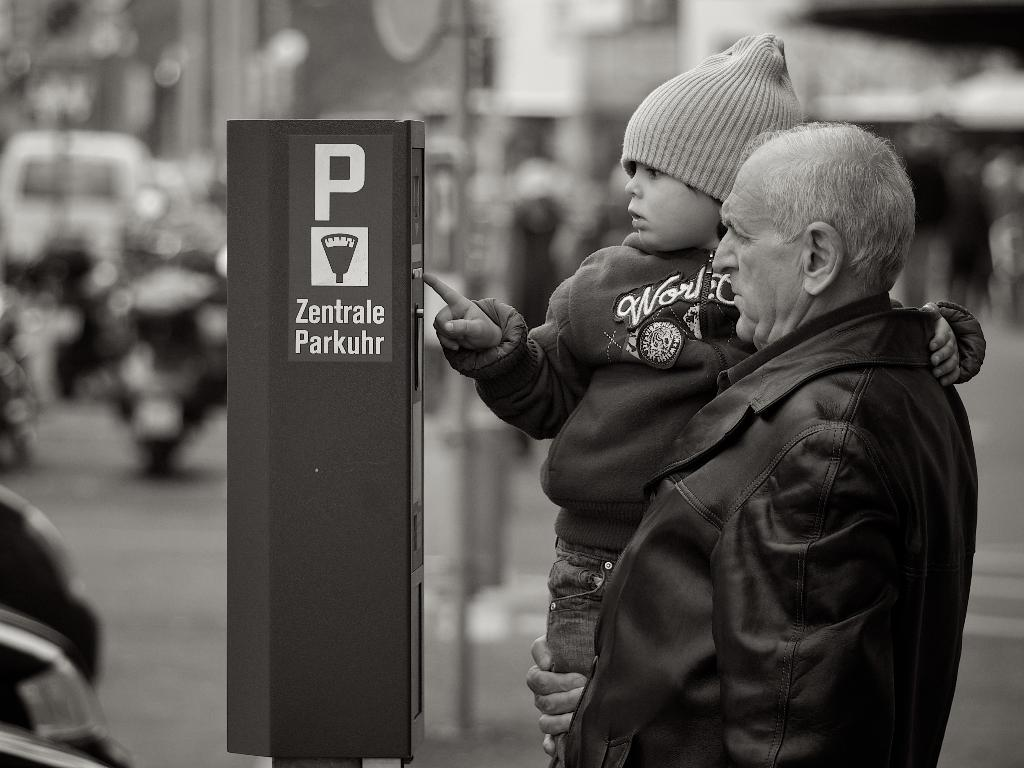<image>
Give a short and clear explanation of the subsequent image. A gray haired man helps a child press some buttons on a Zentrale Parkuhr panel. 